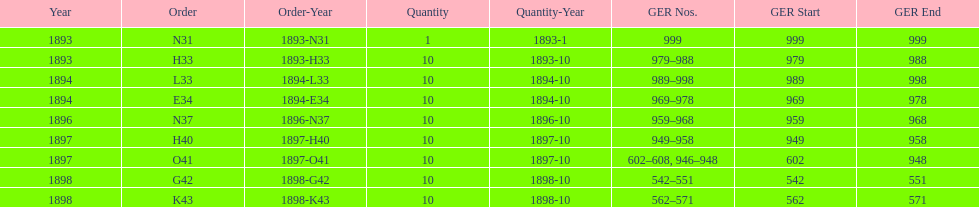What is the total number of locomotives made during this time? 81. 